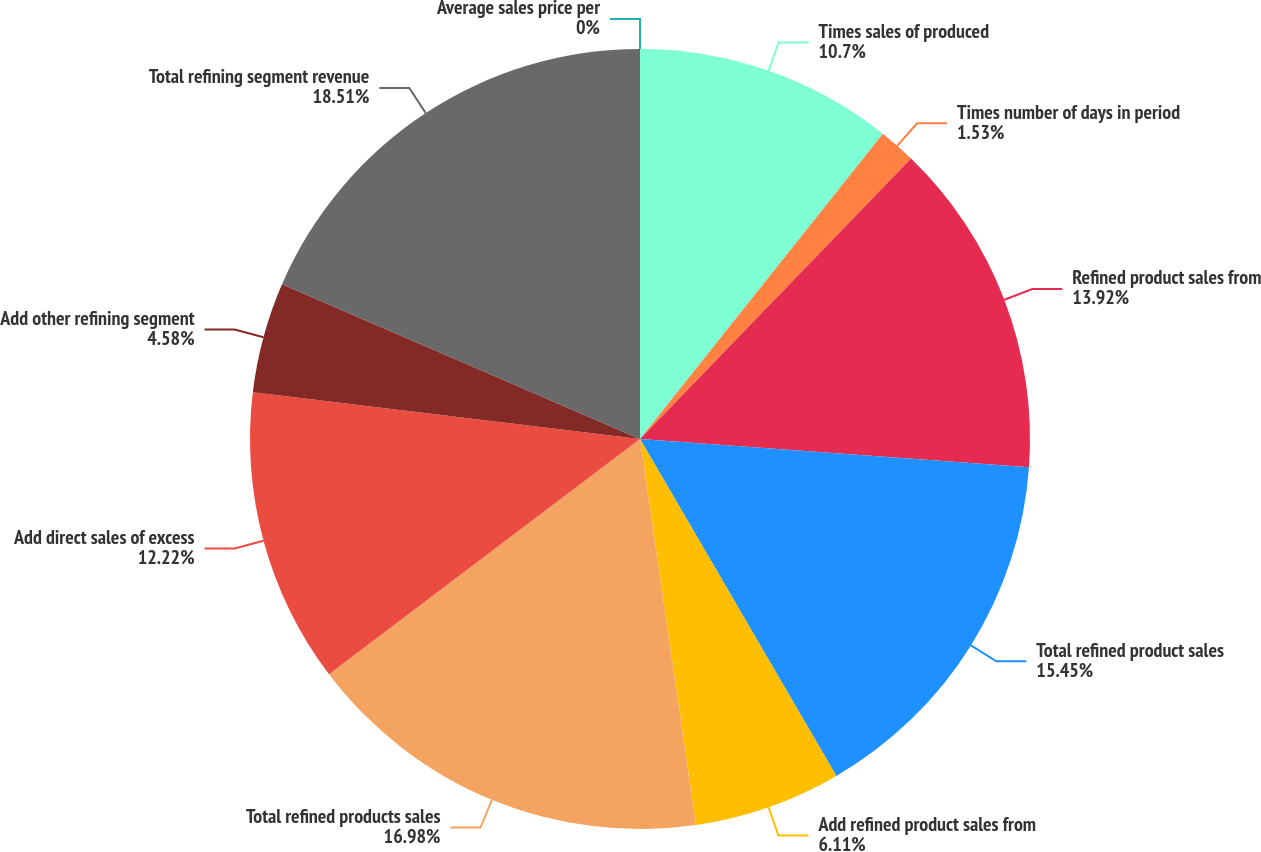Convert chart to OTSL. <chart><loc_0><loc_0><loc_500><loc_500><pie_chart><fcel>Average sales price per<fcel>Times sales of produced<fcel>Times number of days in period<fcel>Refined product sales from<fcel>Total refined product sales<fcel>Add refined product sales from<fcel>Total refined products sales<fcel>Add direct sales of excess<fcel>Add other refining segment<fcel>Total refining segment revenue<nl><fcel>0.0%<fcel>10.7%<fcel>1.53%<fcel>13.92%<fcel>15.45%<fcel>6.11%<fcel>16.98%<fcel>12.22%<fcel>4.58%<fcel>18.51%<nl></chart> 